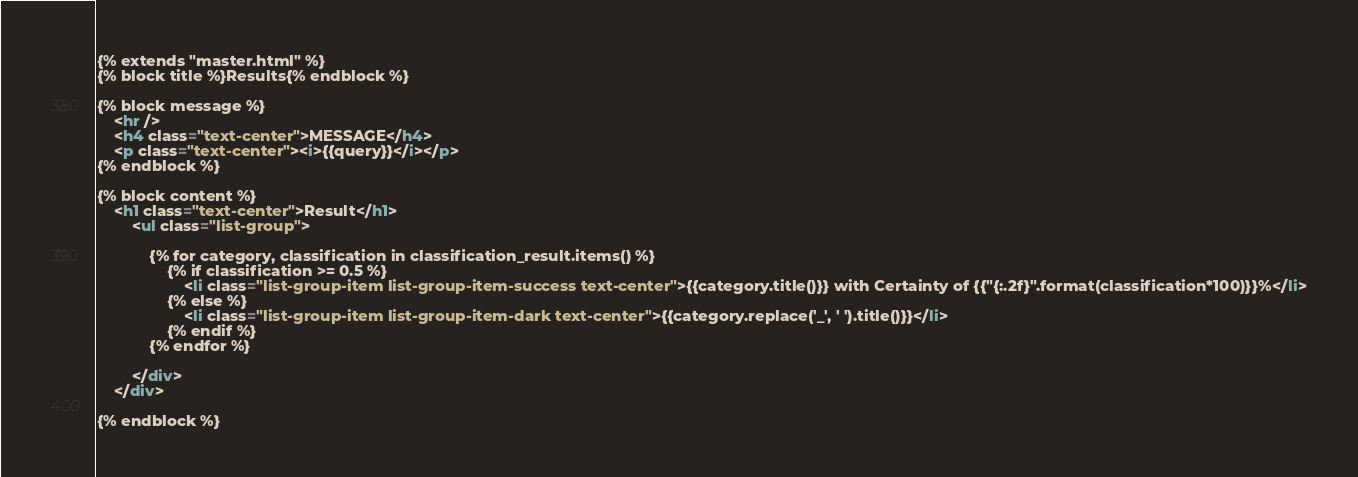<code> <loc_0><loc_0><loc_500><loc_500><_HTML_>{% extends "master.html" %}
{% block title %}Results{% endblock %}

{% block message %}
    <hr />
    <h4 class="text-center">MESSAGE</h4>
    <p class="text-center"><i>{{query}}</i></p>
{% endblock %}

{% block content %}
    <h1 class="text-center">Result</h1>
        <ul class="list-group">

            {% for category, classification in classification_result.items() %}
                {% if classification >= 0.5 %}
                    <li class="list-group-item list-group-item-success text-center">{{category.title()}} with Certainty of {{"{:.2f}".format(classification*100)}}%</li>
                {% else %}
                    <li class="list-group-item list-group-item-dark text-center">{{category.replace('_', ' ').title()}}</li>
                {% endif %}
            {% endfor %}

        </div>
    </div>

{% endblock %}
</code> 